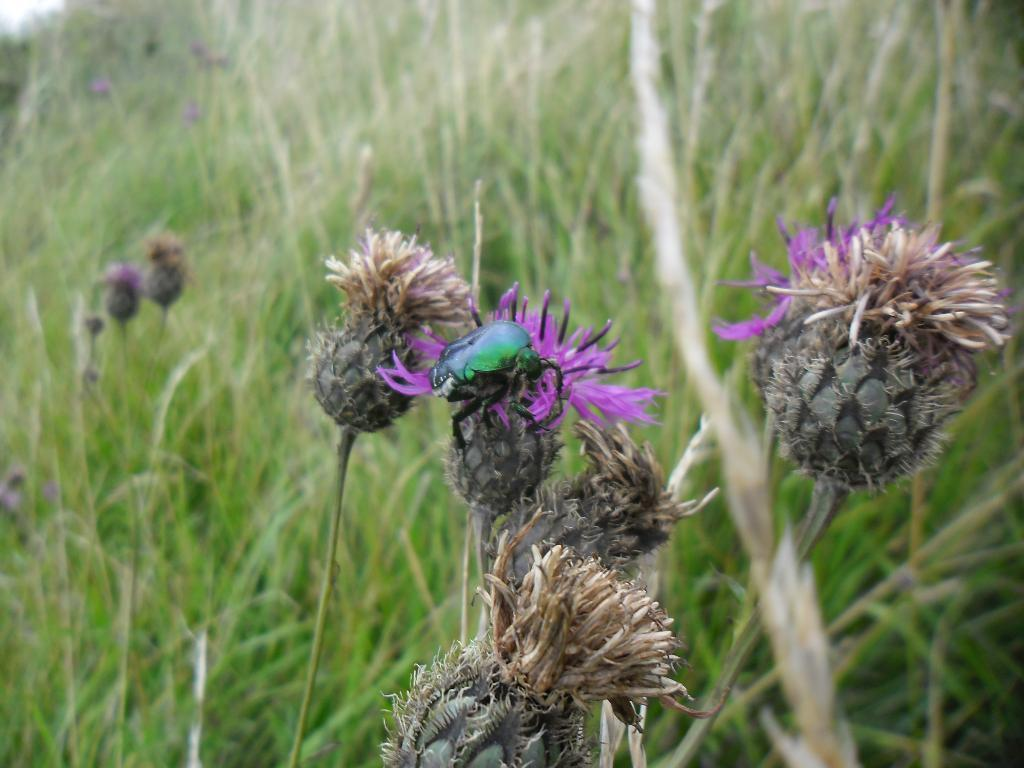What is on the flower in the image? There is a bug on a flower in the image. What type of vegetation can be seen in the image? There is grass and flowers visible in the image. What type of rod is the bug using to communicate with the mailbox in the image? There is no rod or mailbox present in the image; it features a bug on a flower and grass. What authority figure is depicted in the image? There is no authority figure present in the image; it features a bug on a flower and grass. 